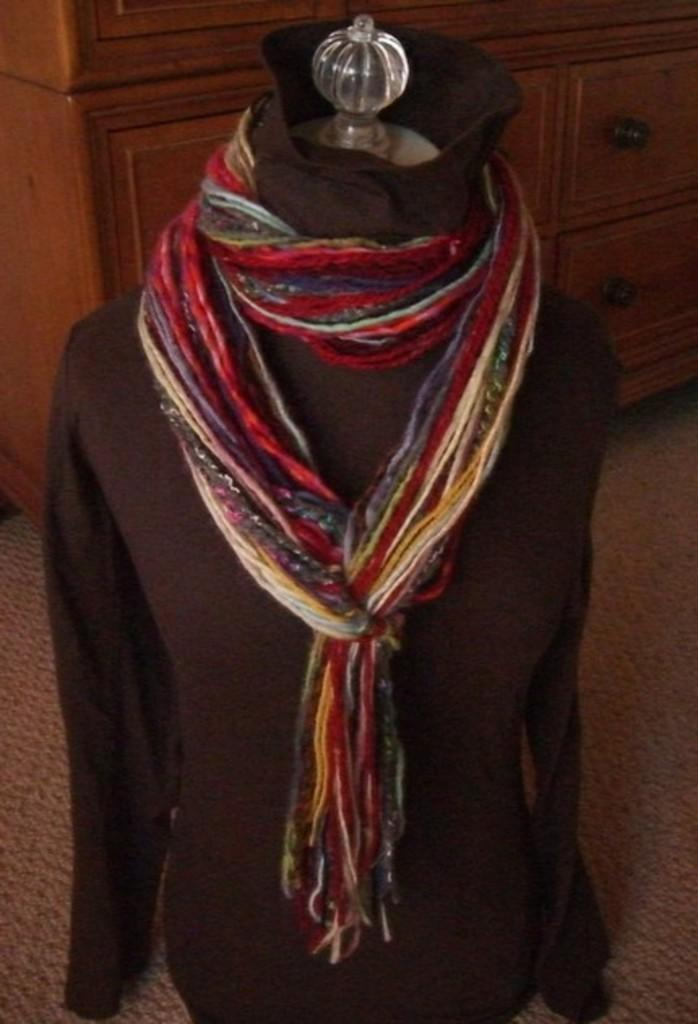What is the main subject in the image? There is a mannequin in the image. How is the mannequin dressed? The mannequin is dressed with a t-shirt and a scarf. Where is the mannequin located in the image? The mannequin is placed on the floor. What can be seen in the background of the image? There is a cupboard in the background of the image. Can you tell me how many goldfish are swimming in the cupboard in the image? There are no goldfish present in the image, and the cupboard is not depicted as containing water for fish to swim in. 